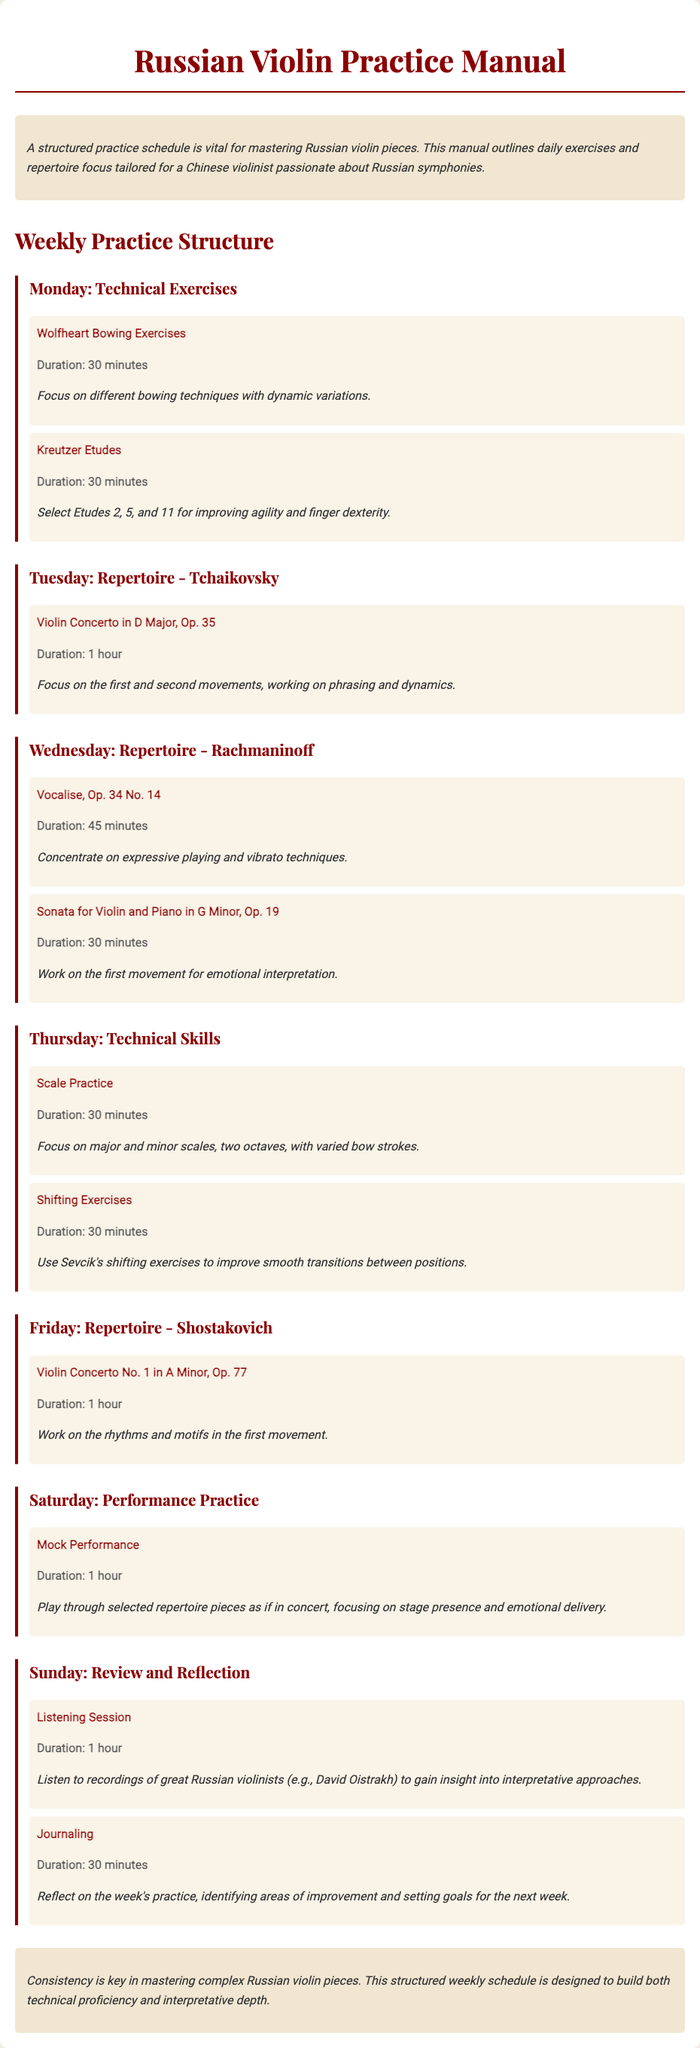What is the title of the manual? The title of the manual is prominently displayed at the top of the document.
Answer: Russian Violin Practice Manual How long should the Wolfheart Bowing Exercises be practiced? The specific duration for practicing the Wolfheart Bowing Exercises is mentioned in the relevant section.
Answer: 30 minutes Which composer's piece is focused on Tuesday? The document specifies the repertoire focused on each day, including the composer for Tuesday.
Answer: Tchaikovsky What is the duration for the Mock Performance on Saturday? The duration is indicated clearly next to the activity listed for Saturday.
Answer: 1 hour How many exercises are listed for Thursday? By counting the exercises under Thursday, the number can be determined directly from the text.
Answer: 2 What is the main focus of the Sunday Listening Session? The purpose of the Sunday Listening Session is described in detail.
Answer: Interpretative approaches Which piece by Rachmaninoff is practiced on Wednesday? The piece is explicitly named in the Wednesday section of the document.
Answer: Vocalise, Op. 34 No. 14 What is emphasized as important in the conclusion? The conclusion summarizes the key focus of the practice schedule.
Answer: Consistency 